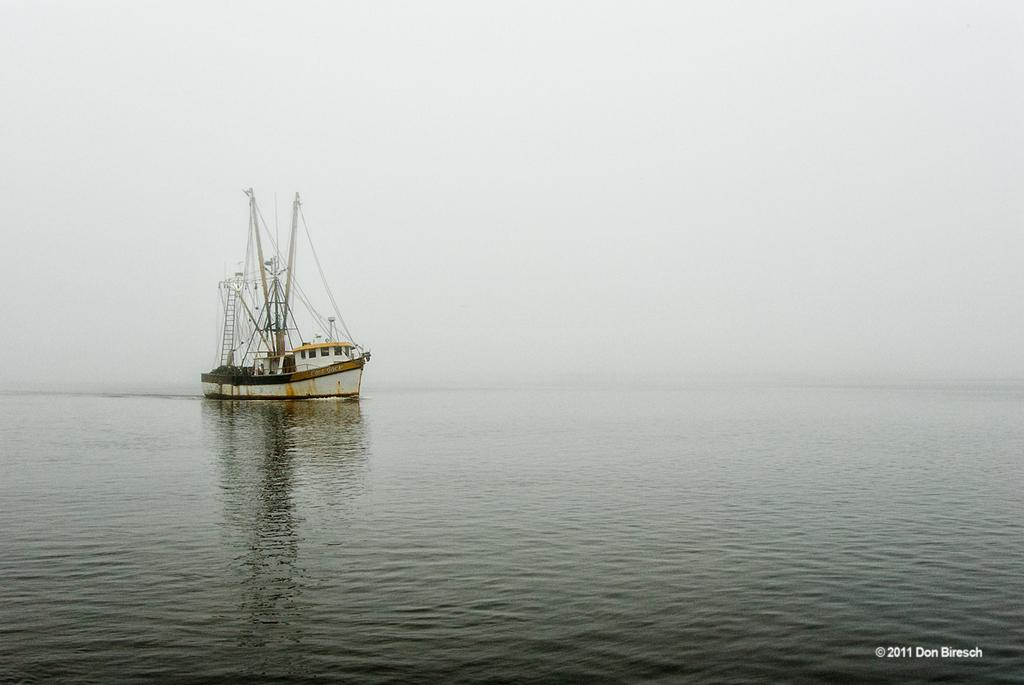What is the main subject in the center of the image? There is a boat in the center of the image. Where is the boat located? The boat is on the water. What can be seen at the bottom right side of the image? There is some text at the bottom right side of the image. What is visible in the background of the image? The sky is visible in the background of the image, and clouds are present. What type of yak can be seen grazing on the sheet in the image? There is no yak or sheet present in the image; it features a boat on the water with a background of sky and clouds. 